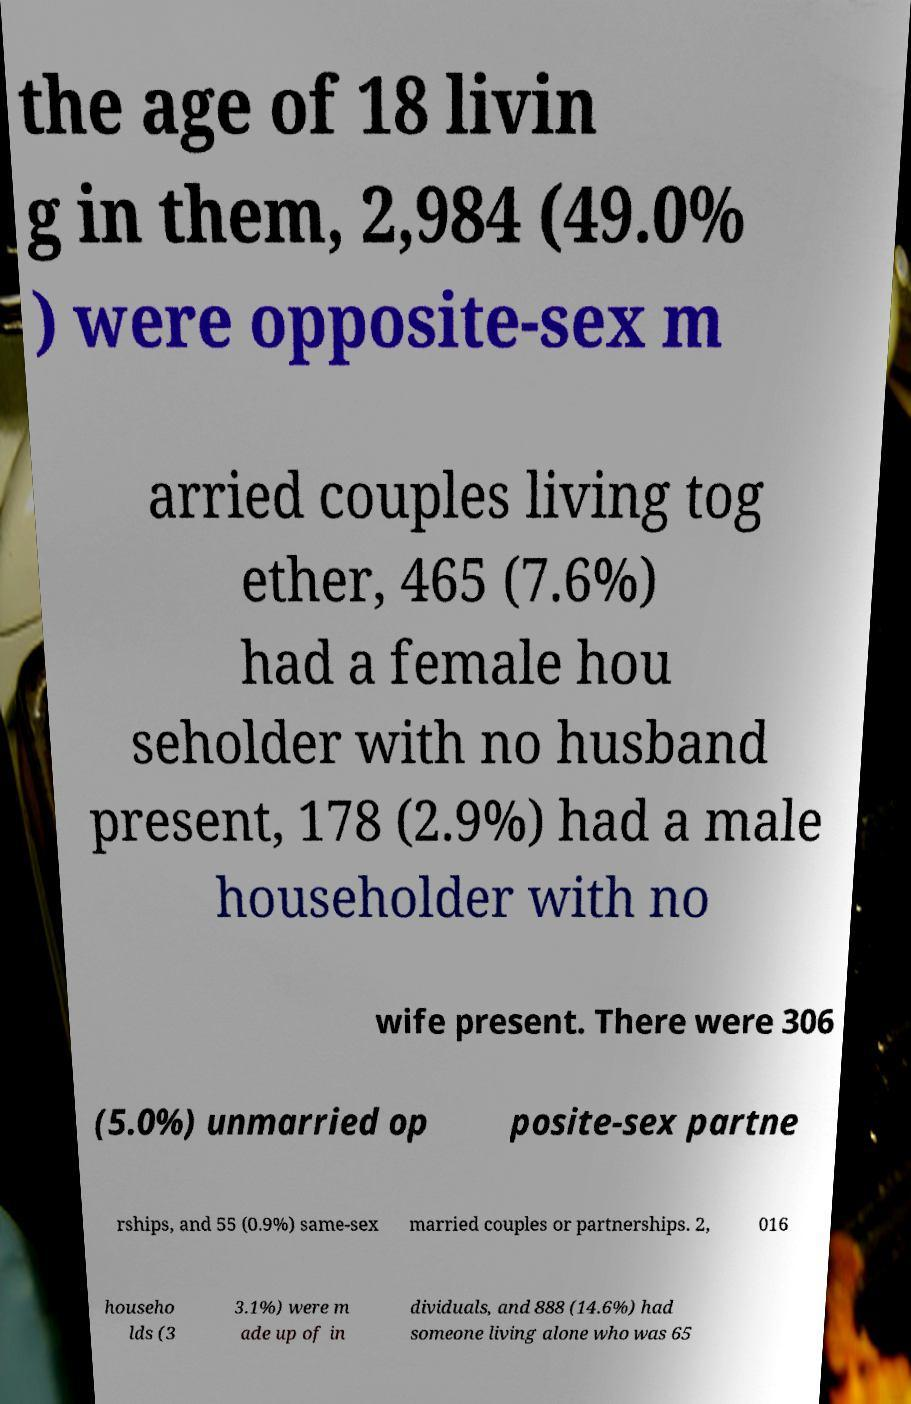I need the written content from this picture converted into text. Can you do that? the age of 18 livin g in them, 2,984 (49.0% ) were opposite-sex m arried couples living tog ether, 465 (7.6%) had a female hou seholder with no husband present, 178 (2.9%) had a male householder with no wife present. There were 306 (5.0%) unmarried op posite-sex partne rships, and 55 (0.9%) same-sex married couples or partnerships. 2, 016 househo lds (3 3.1%) were m ade up of in dividuals, and 888 (14.6%) had someone living alone who was 65 